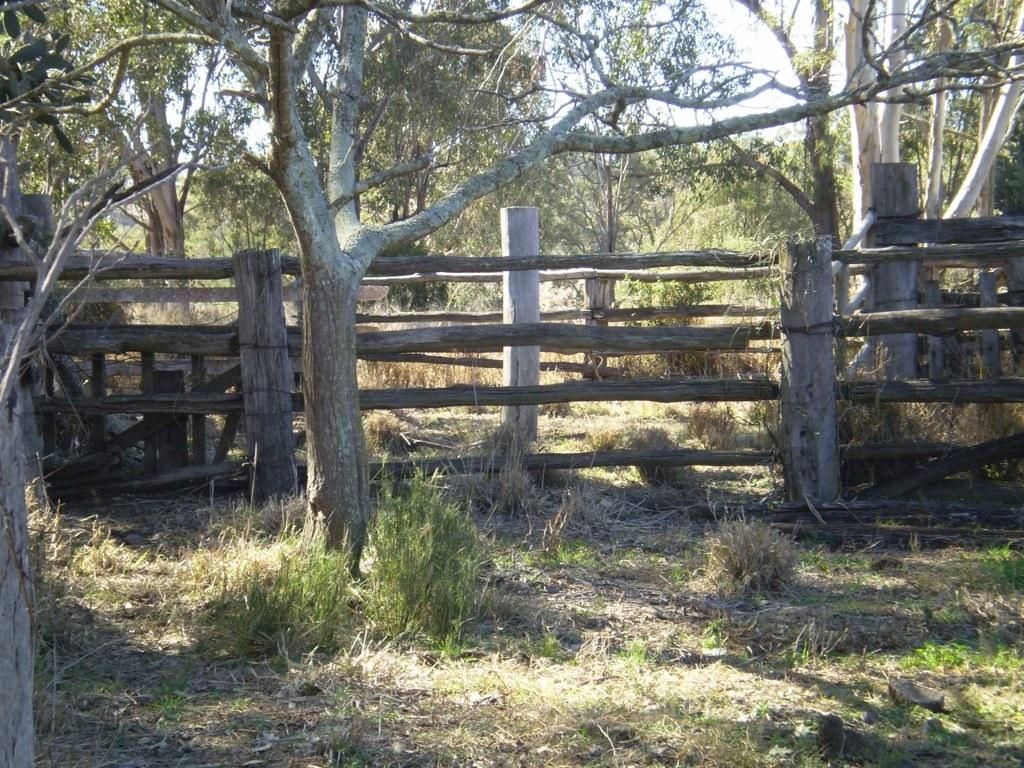What type of vegetation can be seen in the image? There are trees with branches and leaves in the image. What type of barrier is present in the image? There is a wooden fence in the image. What type of ground cover is visible in the image? There is grass visible in the image. Can you see any ghosts walking around in the image? There are no ghosts or any indication of walking in the image; it features trees, a wooden fence, and grass. How many eggs are visible in the image? There are no eggs present in the image. 